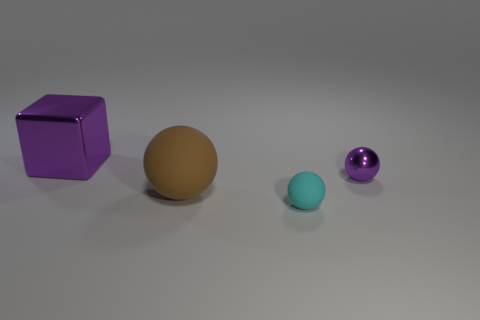There is a metallic thing that is the same color as the metal block; what is its shape?
Your answer should be very brief. Sphere. Is the metallic ball the same color as the large block?
Your answer should be compact. Yes. There is a large object that is behind the brown rubber thing; does it have the same color as the small shiny ball?
Your response must be concise. Yes. Is there anything else that is made of the same material as the large ball?
Give a very brief answer. Yes. What number of cyan objects are matte balls or big metal objects?
Give a very brief answer. 1. What material is the purple object to the right of the large brown matte object?
Provide a short and direct response. Metal. Is the number of tiny yellow rubber cubes greater than the number of tiny metallic things?
Give a very brief answer. No. Is the shape of the purple object on the right side of the large purple cube the same as  the big brown matte thing?
Make the answer very short. Yes. What number of metal things are left of the small purple metallic ball and in front of the purple shiny block?
Provide a succinct answer. 0. How many large brown objects are the same shape as the small metallic thing?
Your answer should be very brief. 1. 